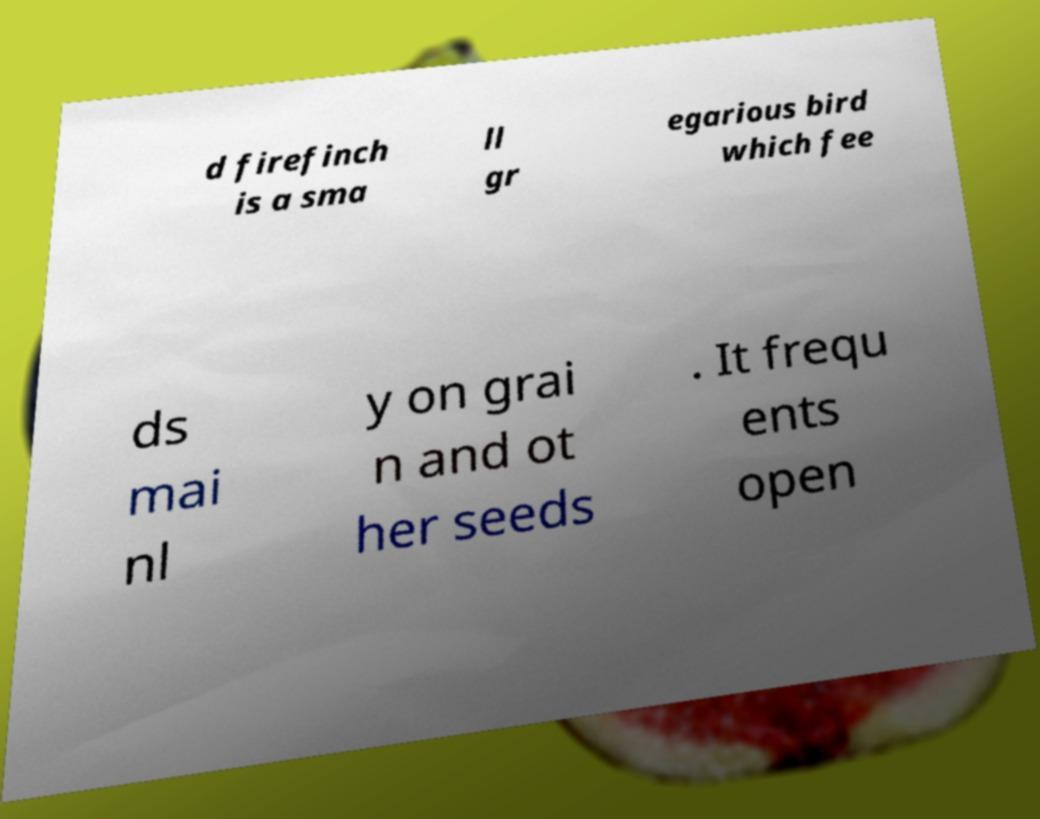Please read and relay the text visible in this image. What does it say? d firefinch is a sma ll gr egarious bird which fee ds mai nl y on grai n and ot her seeds . It frequ ents open 